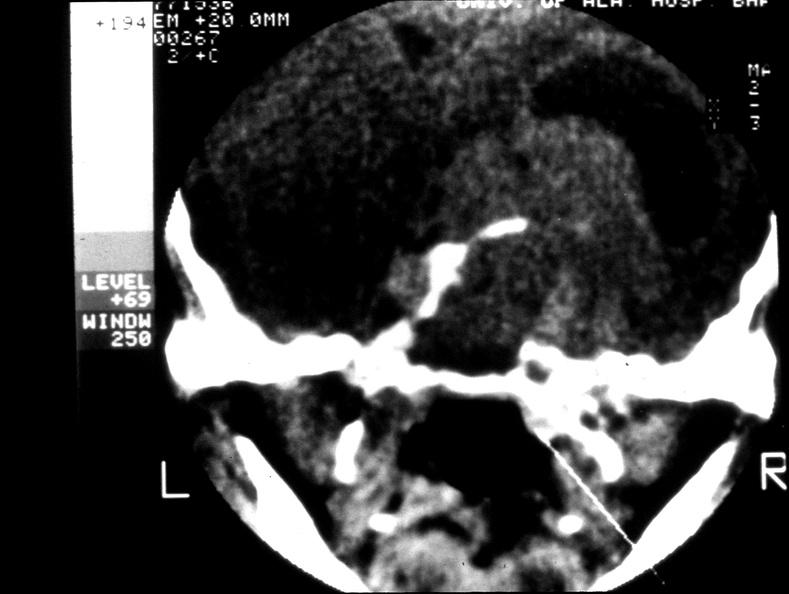what is present?
Answer the question using a single word or phrase. Endocrine 